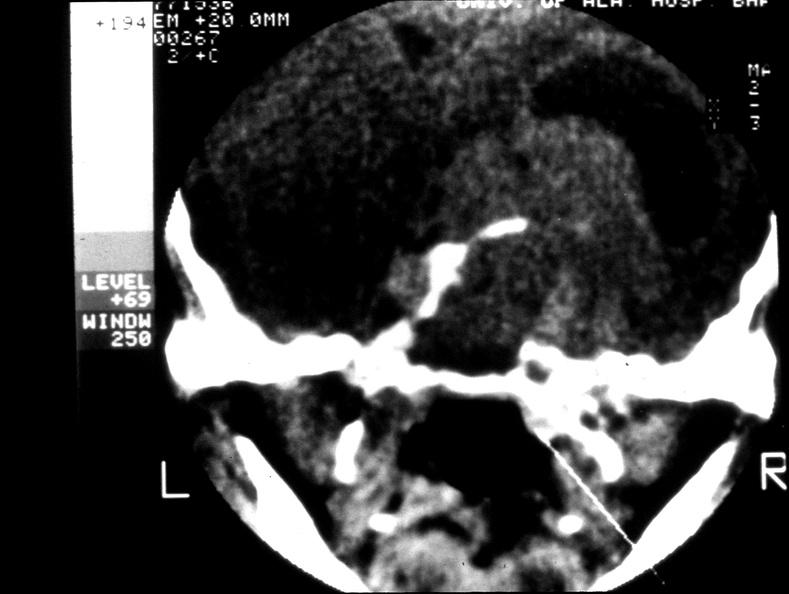what is present?
Answer the question using a single word or phrase. Endocrine 